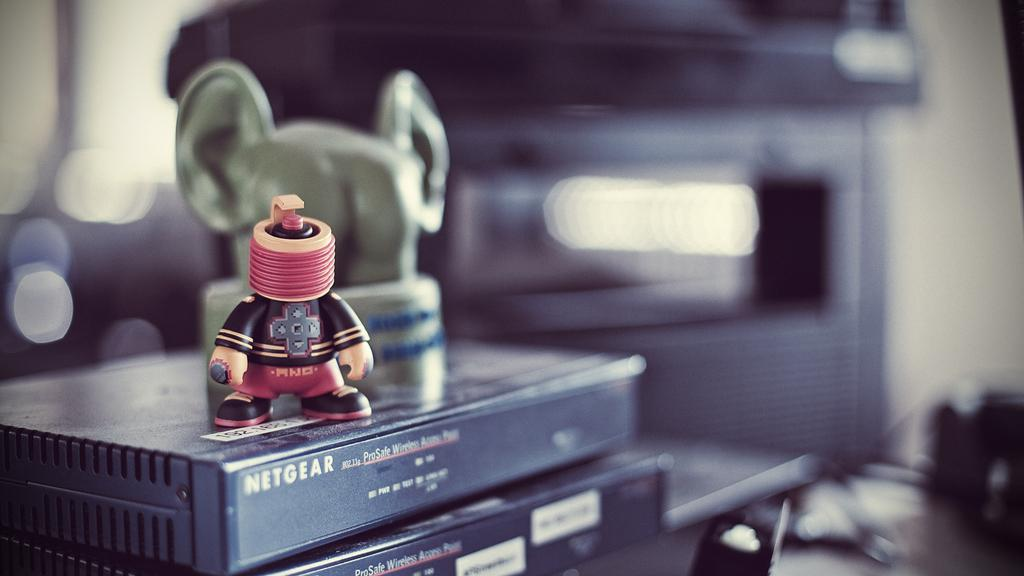<image>
Write a terse but informative summary of the picture. A toy figure sits on a Netgear black electronic box. 